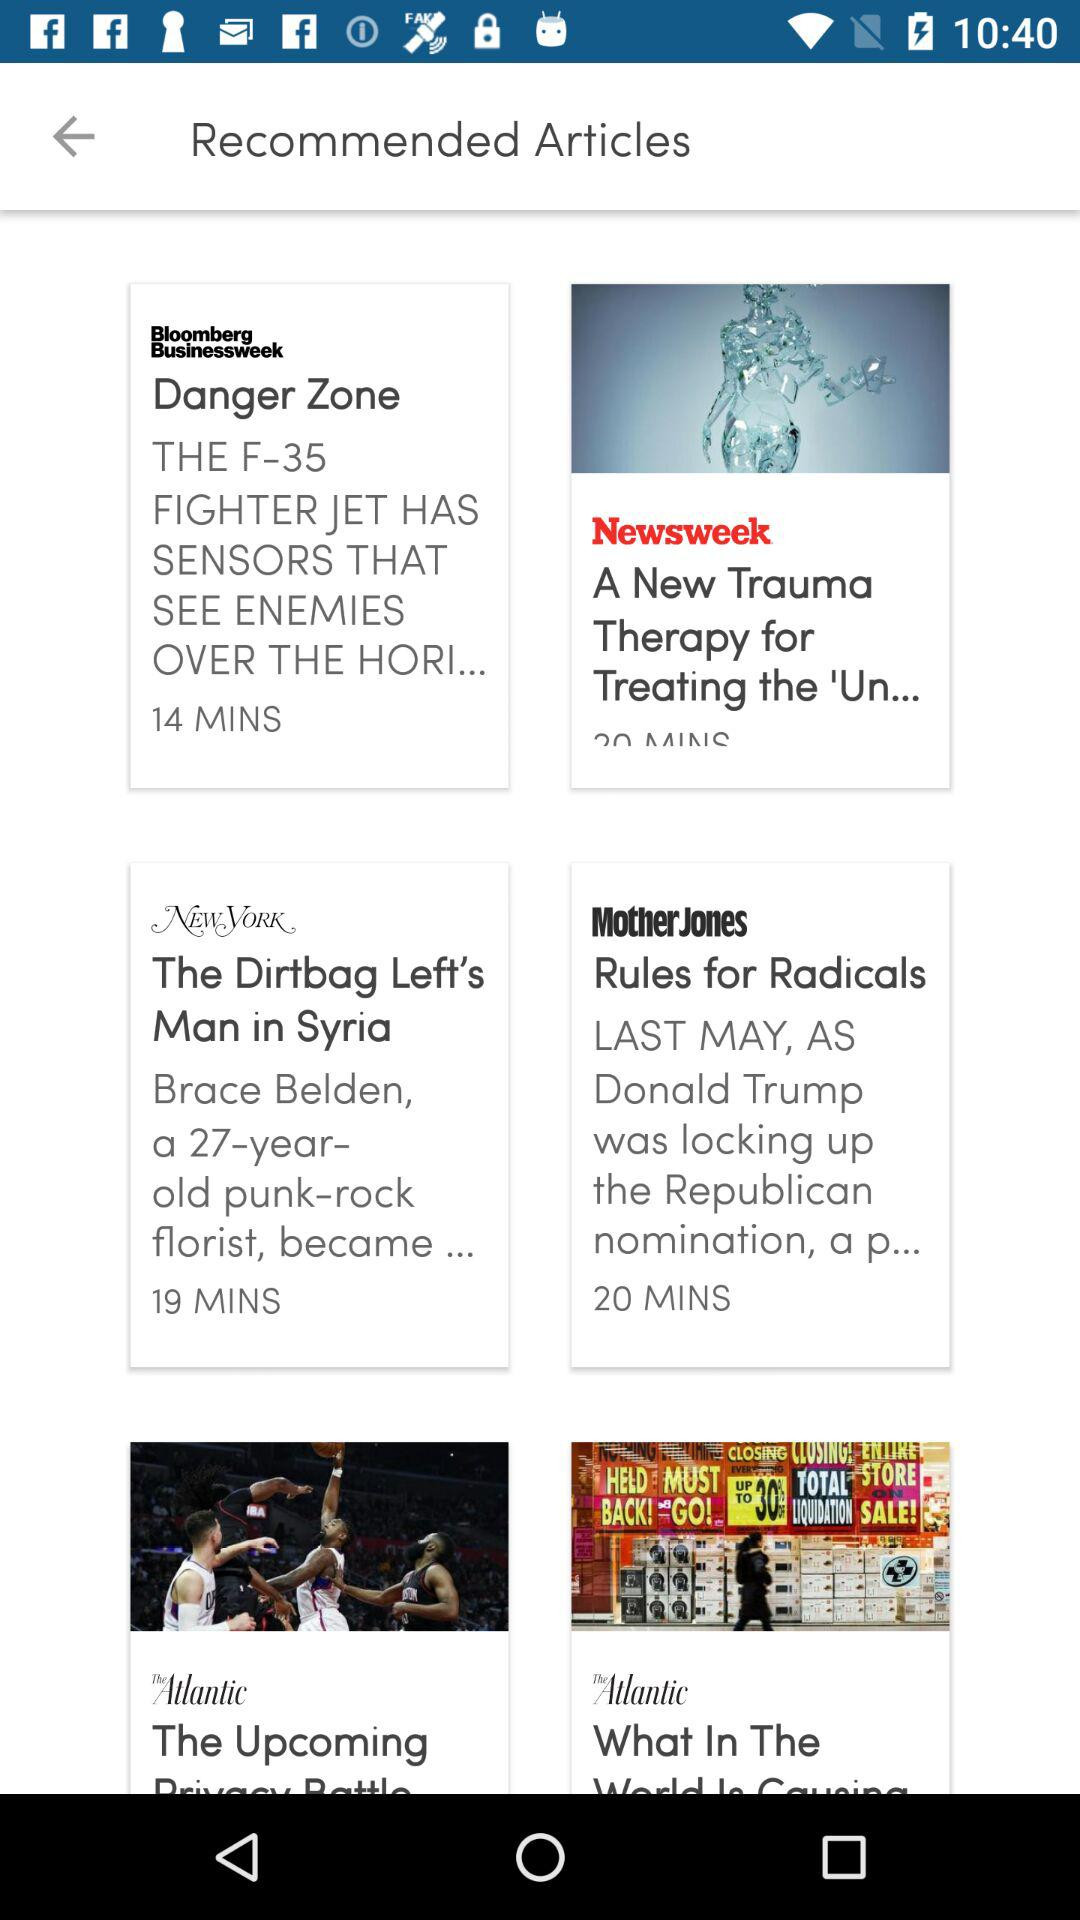Which article was published 20 minutes ago? The article that was published 20 minutes ago is "Rules for Radicals". 